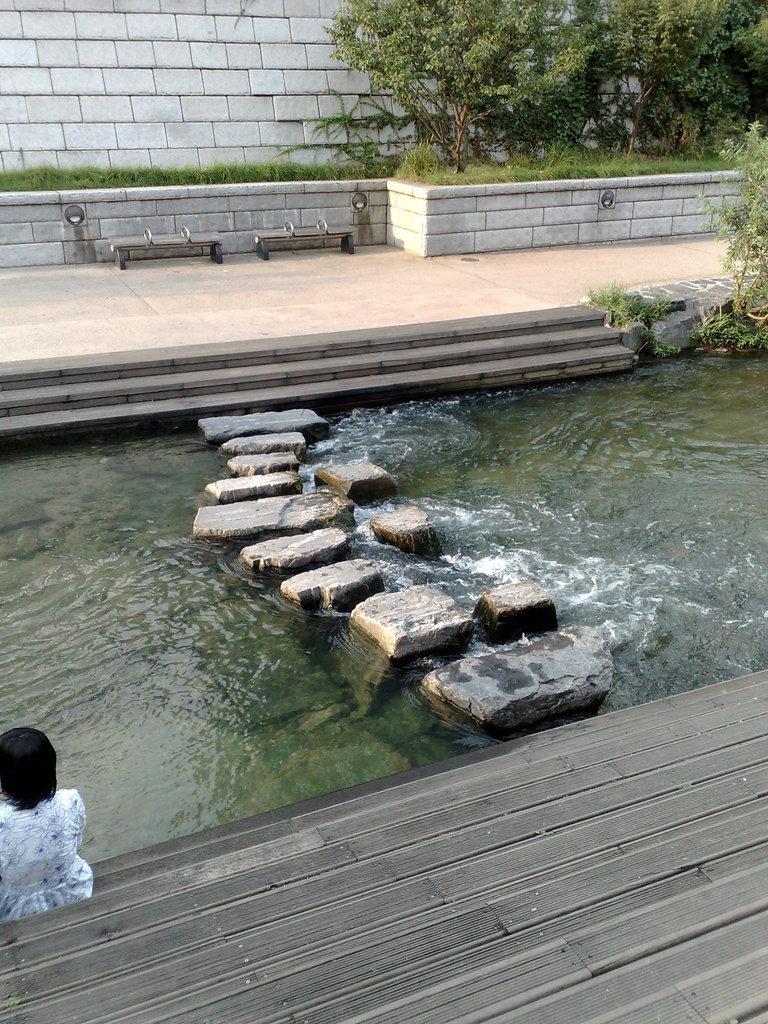Please provide a concise description of this image. In this image we can see walls, trees, grass, benches, stairs, rocks above the water and a person sitting on the floor. 